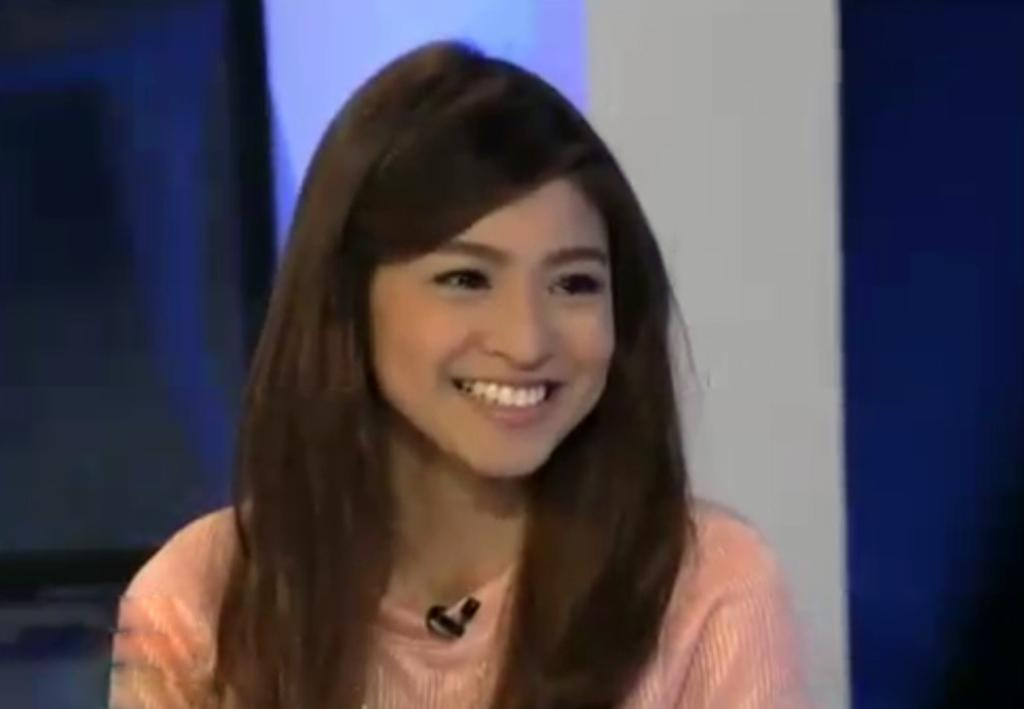Who is present in the image? There is a woman in the image. What is the woman wearing? The woman is wearing a cream-colored dress. What expression does the woman have? The woman is smiling. What object can be seen in the image that is typically used for amplifying sound? There is a microphone (mic) in the image. What type of wool is the woman using to sneeze in the image? There is no wool or sneezing present in the image; the woman is smiling and there is a microphone nearby. 